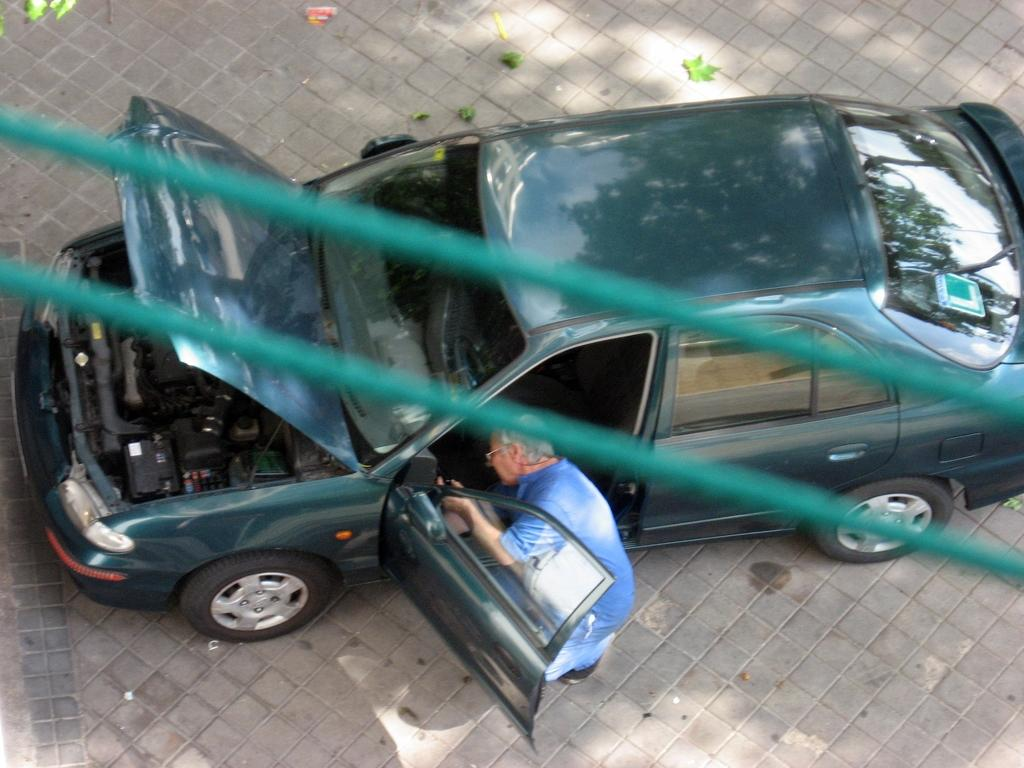What is located on the ground in the image? There is a car parked on the ground in the image. Can you describe the person in the image? There is a person standing in the image. What is the person holding in his hand? The person is holding an object in his hand. What can be seen in the foreground of the image? There are cables visible in the foreground of the image. What type of toad can be seen sneezing in the image? There is no toad present in the image, nor is there any sneezing. 